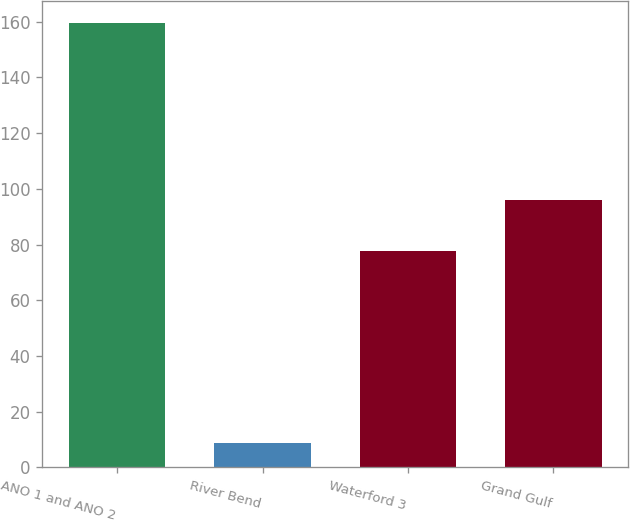<chart> <loc_0><loc_0><loc_500><loc_500><bar_chart><fcel>ANO 1 and ANO 2<fcel>River Bend<fcel>Waterford 3<fcel>Grand Gulf<nl><fcel>159.5<fcel>8.7<fcel>77.7<fcel>96.1<nl></chart> 